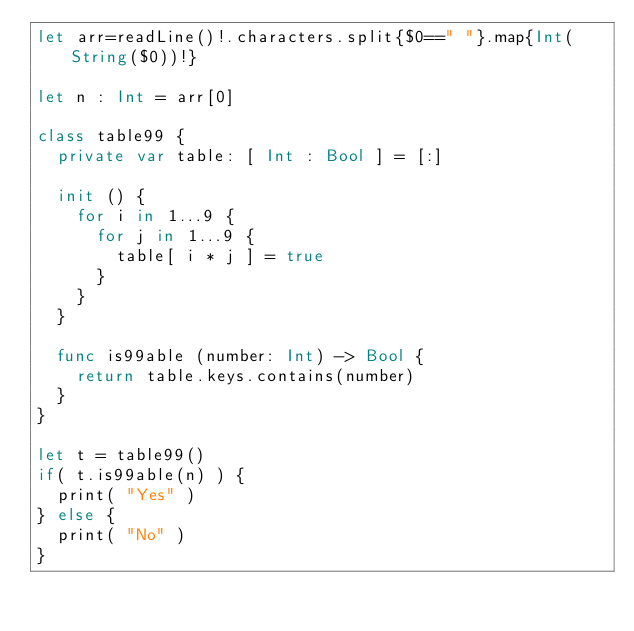<code> <loc_0><loc_0><loc_500><loc_500><_Swift_>let arr=readLine()!.characters.split{$0==" "}.map{Int(String($0))!}

let n : Int = arr[0]

class table99 {
  private var table: [ Int : Bool ] = [:]
  
  init () {
    for i in 1...9 {
      for j in 1...9 {
        table[ i * j ] = true
      }
    }
  }
  
  func is99able (number: Int) -> Bool {
    return table.keys.contains(number)
  }
}

let t = table99()
if( t.is99able(n) ) {
  print( "Yes" )
} else {
  print( "No" )
}</code> 